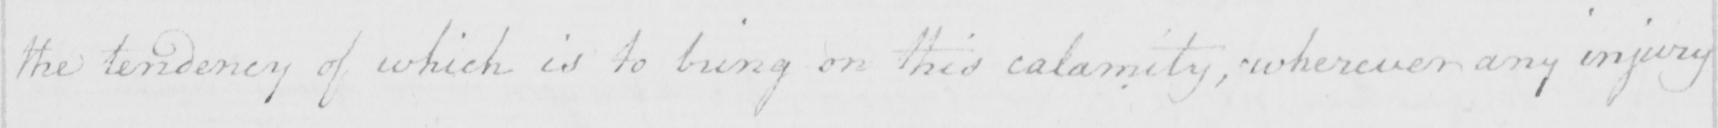What text is written in this handwritten line? the tendency of which is to bring on this calamity , wherever any injury 